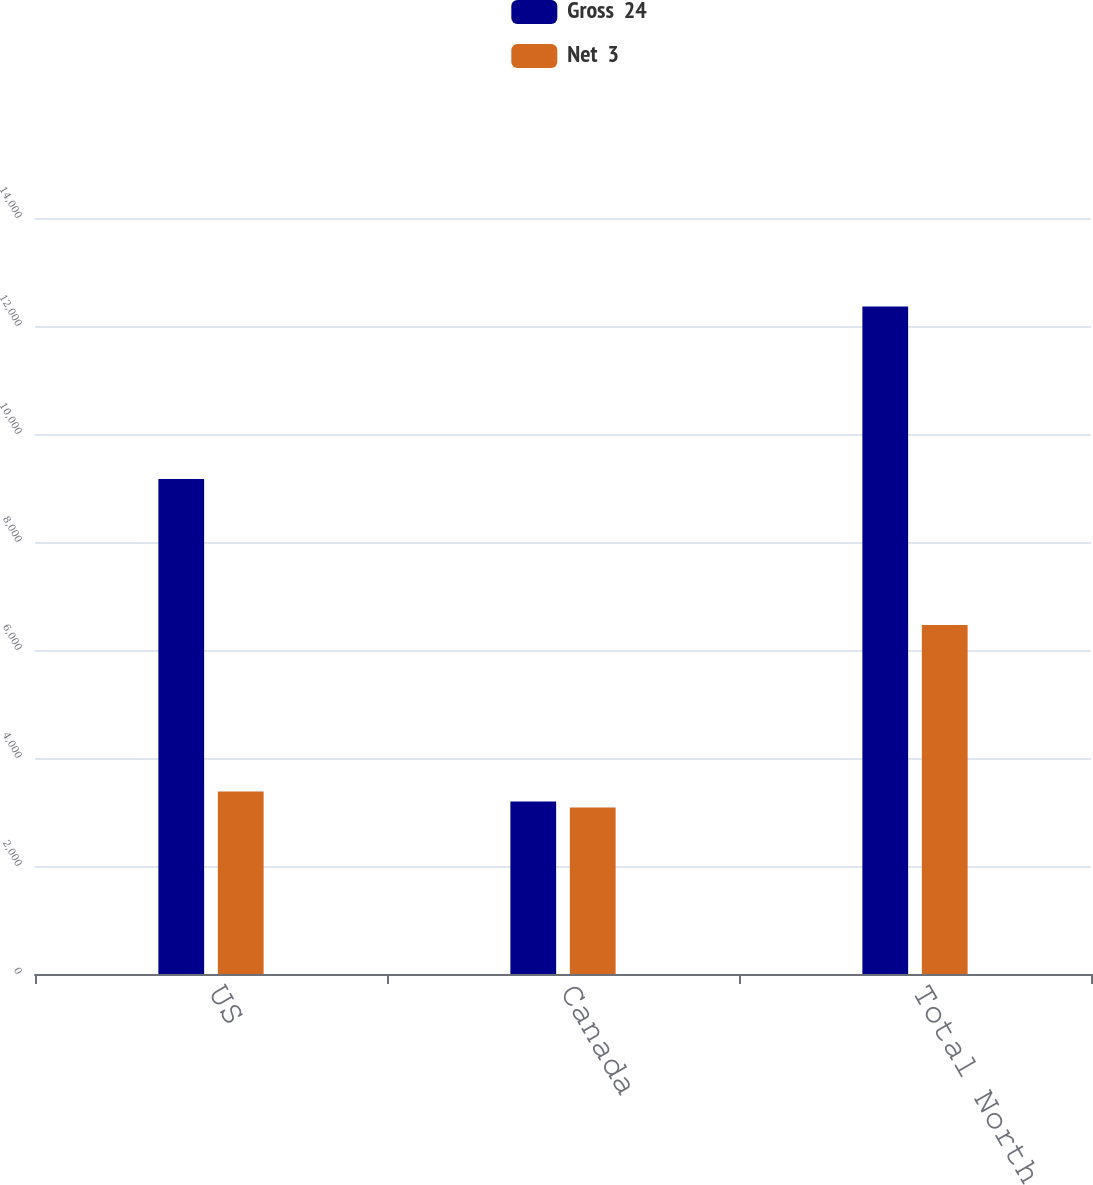Convert chart. <chart><loc_0><loc_0><loc_500><loc_500><stacked_bar_chart><ecel><fcel>US<fcel>Canada<fcel>Total North America<nl><fcel>Gross  24<fcel>9165<fcel>3195<fcel>12360<nl><fcel>Net  3<fcel>3379<fcel>3085<fcel>6464<nl></chart> 